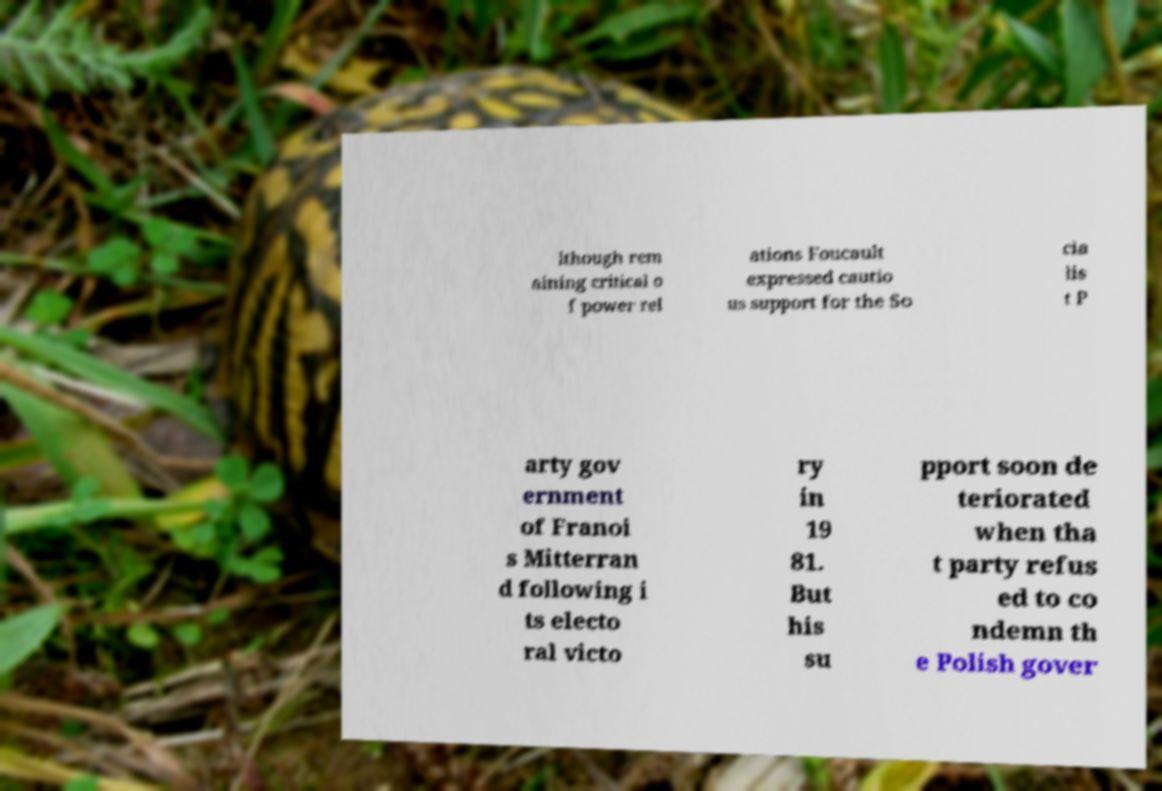Please read and relay the text visible in this image. What does it say? lthough rem aining critical o f power rel ations Foucault expressed cautio us support for the So cia lis t P arty gov ernment of Franoi s Mitterran d following i ts electo ral victo ry in 19 81. But his su pport soon de teriorated when tha t party refus ed to co ndemn th e Polish gover 